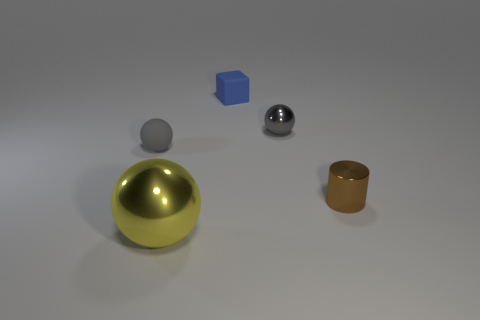Is the color of the small cylinder the same as the big metal object?
Ensure brevity in your answer.  No. What number of other things are the same shape as the blue object?
Offer a terse response. 0. What number of blue objects are either blocks or large shiny spheres?
Ensure brevity in your answer.  1. There is a small ball that is the same material as the yellow thing; what is its color?
Your response must be concise. Gray. Is the material of the sphere in front of the tiny shiny cylinder the same as the small sphere that is on the right side of the large yellow metal thing?
Your response must be concise. Yes. What is the size of the other ball that is the same color as the tiny metal ball?
Your answer should be compact. Small. What is the block right of the small gray matte thing made of?
Your response must be concise. Rubber. Does the object left of the yellow thing have the same shape as the matte thing on the right side of the yellow thing?
Your response must be concise. No. What is the material of the tiny object that is the same color as the rubber ball?
Give a very brief answer. Metal. Is there a tiny cube?
Your answer should be compact. Yes. 